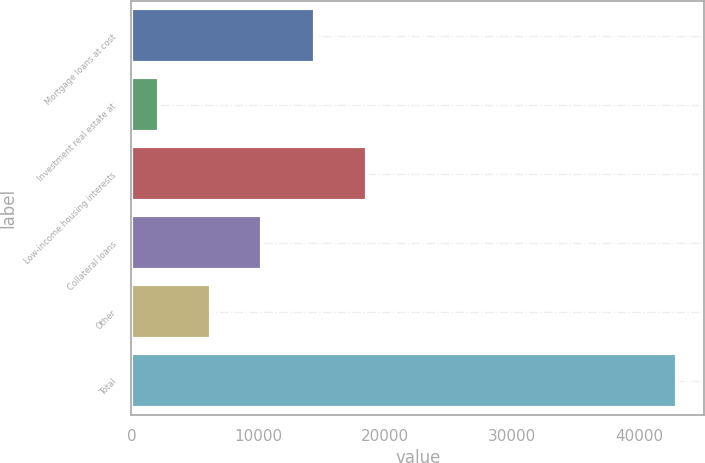Convert chart. <chart><loc_0><loc_0><loc_500><loc_500><bar_chart><fcel>Mortgage loans at cost<fcel>Investment real estate at<fcel>Low-income housing interests<fcel>Collateral loans<fcel>Other<fcel>Total<nl><fcel>14481<fcel>2154<fcel>18564.1<fcel>10320.2<fcel>6237.1<fcel>42985<nl></chart> 